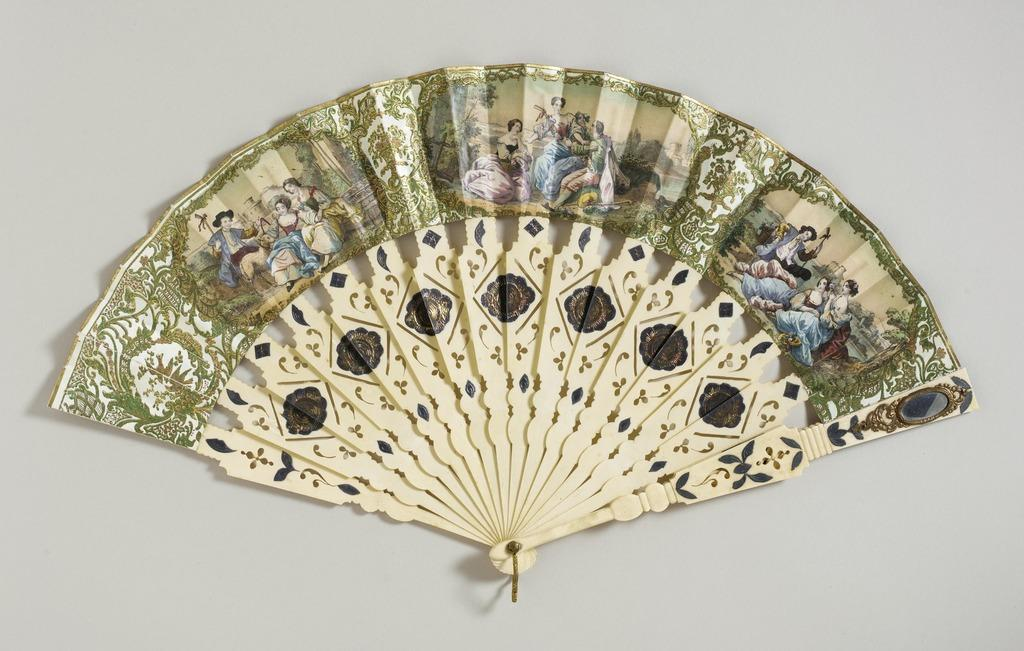What is depicted on the hand fan in the image? There are paintings on a hand fan, which include persons, trees, water, sky, and other designs. How is the hand fan positioned in the image? The hand fan is placed on a surface. What is the color of the background in the image? The background is white in color. What type of rail can be seen in the image? There is no rail present in the image; it features a hand fan with paintings. How many curves are visible in the route depicted in the image? There is no route or curve present in the image; it features a hand fan with paintings. 